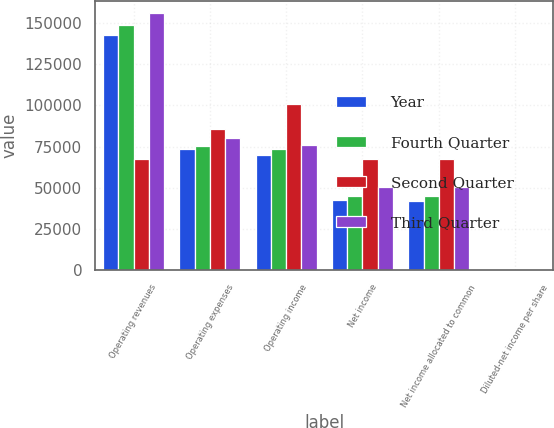Convert chart to OTSL. <chart><loc_0><loc_0><loc_500><loc_500><stacked_bar_chart><ecel><fcel>Operating revenues<fcel>Operating expenses<fcel>Operating income<fcel>Net income<fcel>Net income allocated to common<fcel>Diluted-net income per share<nl><fcel>Year<fcel>142839<fcel>73286<fcel>69553<fcel>42259<fcel>42079<fcel>0.5<nl><fcel>Fourth Quarter<fcel>148725<fcel>75355<fcel>73370<fcel>44845<fcel>44646<fcel>0.54<nl><fcel>Second Quarter<fcel>67516<fcel>85925<fcel>101110<fcel>67516<fcel>67219<fcel>0.81<nl><fcel>Third Quarter<fcel>155946<fcel>80051<fcel>75895<fcel>50403<fcel>50181<fcel>0.61<nl></chart> 